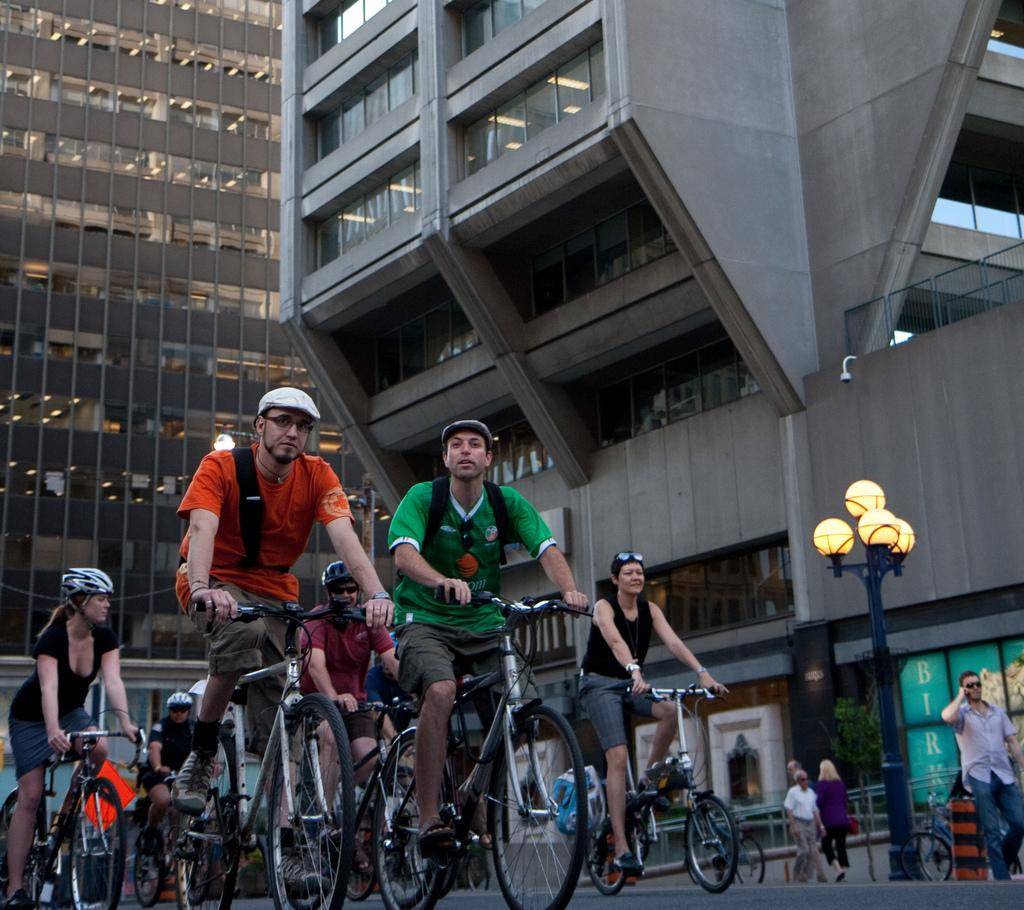What are the persons in the image doing? Some persons are riding bicycles, and some are walking. What safety precaution are the persons riding bicycles taking? The persons riding bicycles are wearing helmets. What structures can be seen in the image? There are buildings and a light pole in the image. How can you tell that some persons are walking? The leg movement of the persons indicates that they are walking. How many pizzas are being held by the persons walking in the image? There are no pizzas visible in the image; the persons are walking without any pizzas. What is the price of the thumb in the image? There is no thumb or price mentioned in the image; it only features persons riding bicycles, walking, and wearing helmets, as well as buildings and a light pole. 